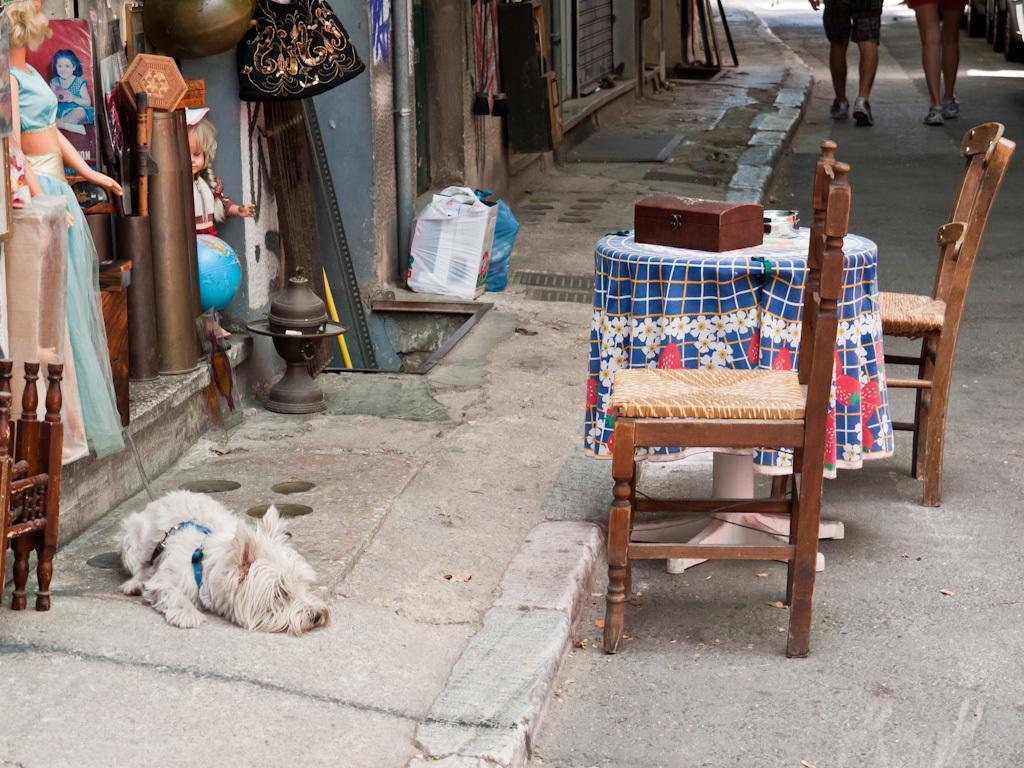Please provide a concise description of this image. In this image there is a dog which is sleeping on the floor and at the top of the image there are two persons walking on the road and there are chairs,table and at the left side of the image there are dolls. 